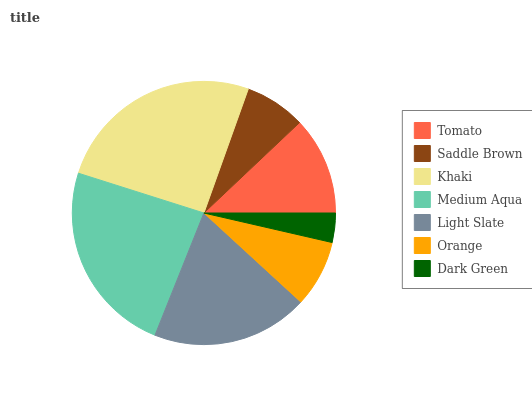Is Dark Green the minimum?
Answer yes or no. Yes. Is Khaki the maximum?
Answer yes or no. Yes. Is Saddle Brown the minimum?
Answer yes or no. No. Is Saddle Brown the maximum?
Answer yes or no. No. Is Tomato greater than Saddle Brown?
Answer yes or no. Yes. Is Saddle Brown less than Tomato?
Answer yes or no. Yes. Is Saddle Brown greater than Tomato?
Answer yes or no. No. Is Tomato less than Saddle Brown?
Answer yes or no. No. Is Tomato the high median?
Answer yes or no. Yes. Is Tomato the low median?
Answer yes or no. Yes. Is Saddle Brown the high median?
Answer yes or no. No. Is Medium Aqua the low median?
Answer yes or no. No. 